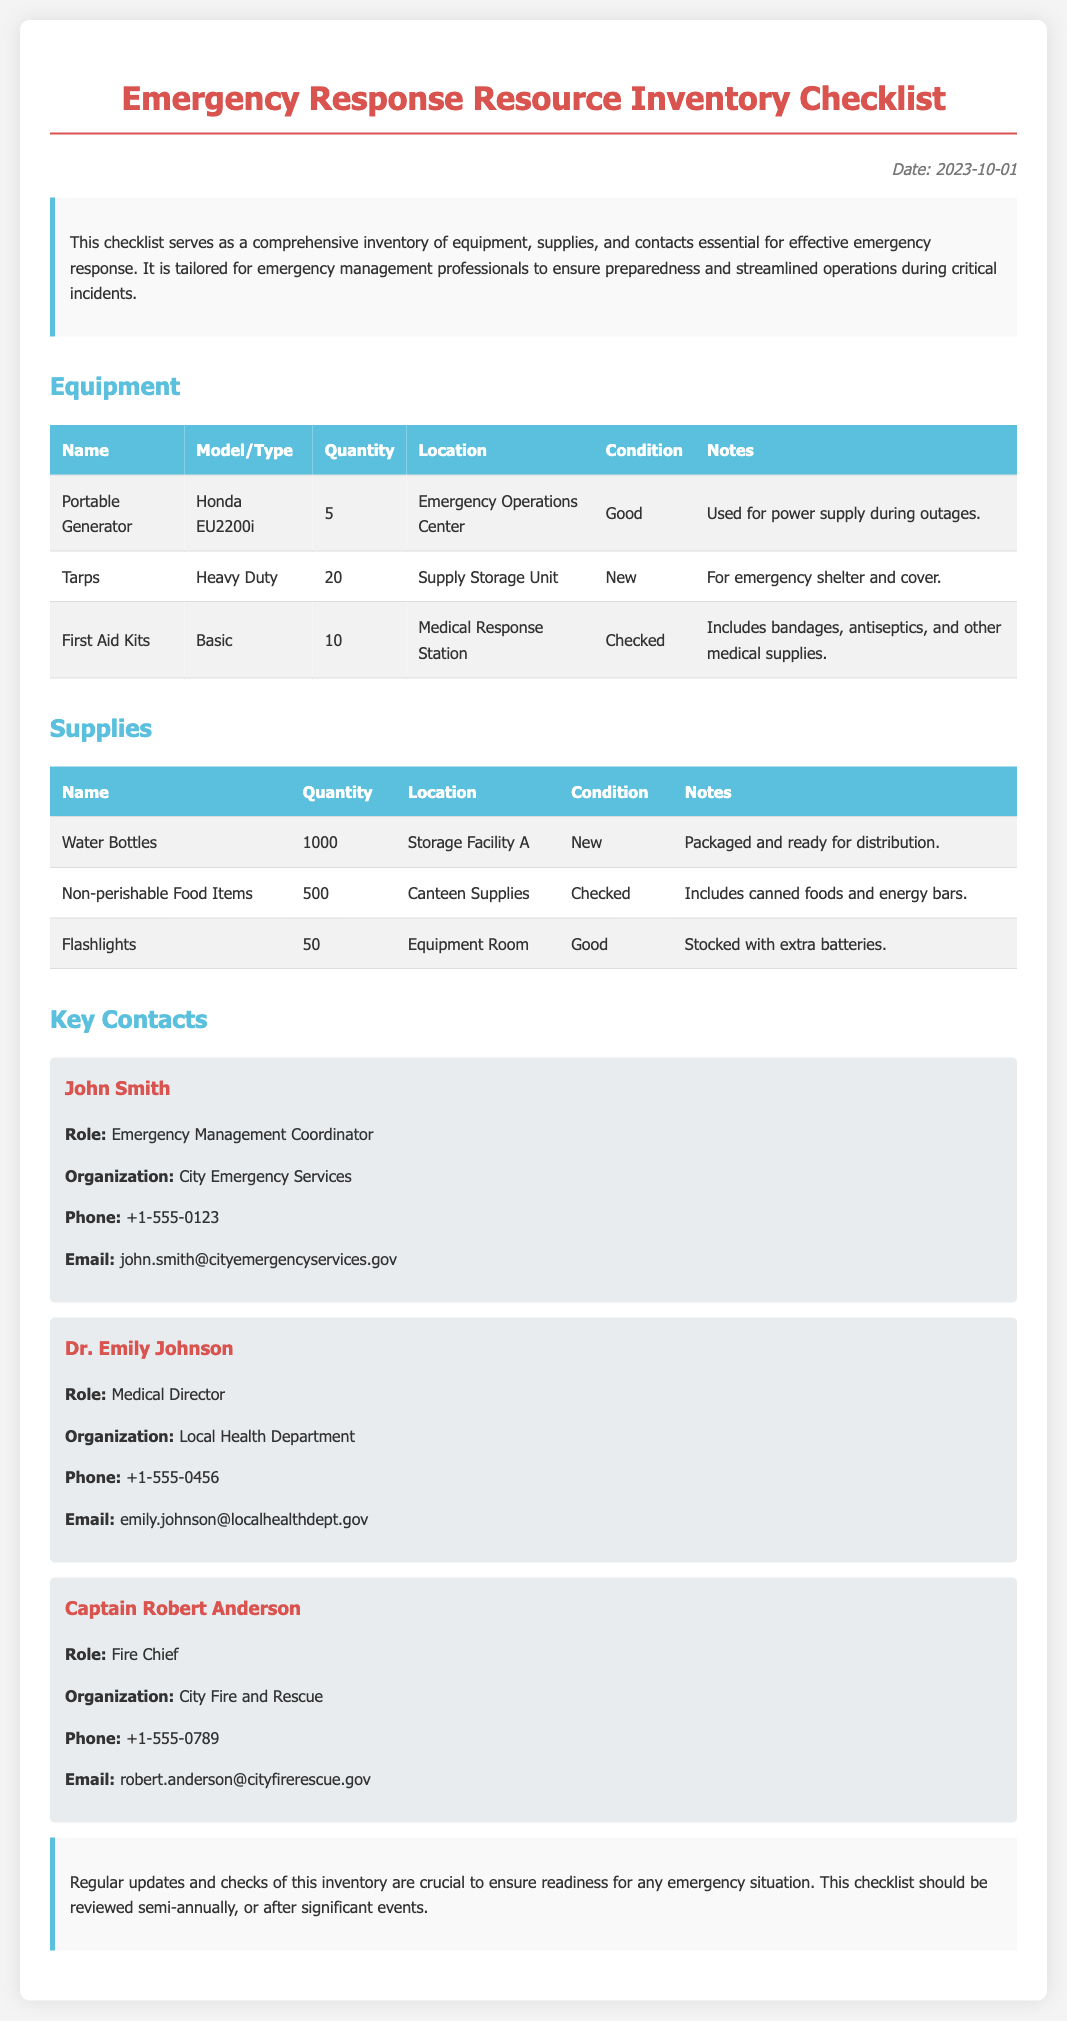what is the date on the document? The date is mentioned in the top right corner of the document.
Answer: 2023-10-01 how many portable generators are available? The quantity of portable generators is listed in the equipment section.
Answer: 5 where are the first aid kits located? The location for first aid kits can be found in the equipment table.
Answer: Medical Response Station what is the condition of the tarps? The condition is provided in the equipment section for the tarps.
Answer: New who is the Emergency Management Coordinator? The document lists key contacts including their roles and organizations.
Answer: John Smith how many water bottles are listed in the supplies? This number is provided in the supplies section of the checklist.
Answer: 1000 what is the purpose of the portable generators? The notes about each equipment item describe their intended usage.
Answer: Used for power supply during outages how often should the inventory be reviewed? This information is mentioned in the conclusion section of the document.
Answer: Semi-annually which organization is Dr. Emily Johnson affiliated with? The organization for each key contact is specified in their contact details.
Answer: Local Health Department 